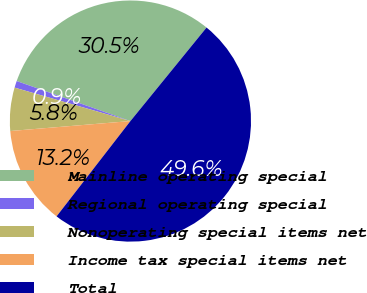Convert chart. <chart><loc_0><loc_0><loc_500><loc_500><pie_chart><fcel>Mainline operating special<fcel>Regional operating special<fcel>Nonoperating special items net<fcel>Income tax special items net<fcel>Total<nl><fcel>30.49%<fcel>0.91%<fcel>5.79%<fcel>13.19%<fcel>49.62%<nl></chart> 